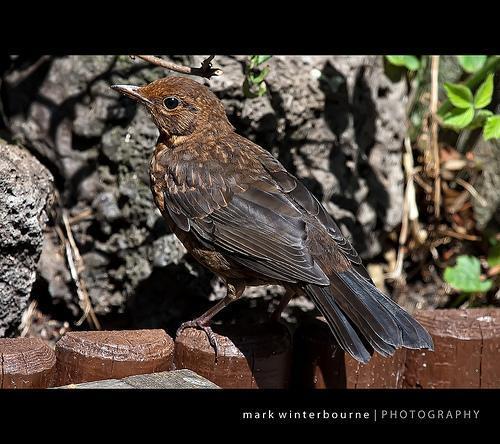How many birds are there?
Give a very brief answer. 1. 